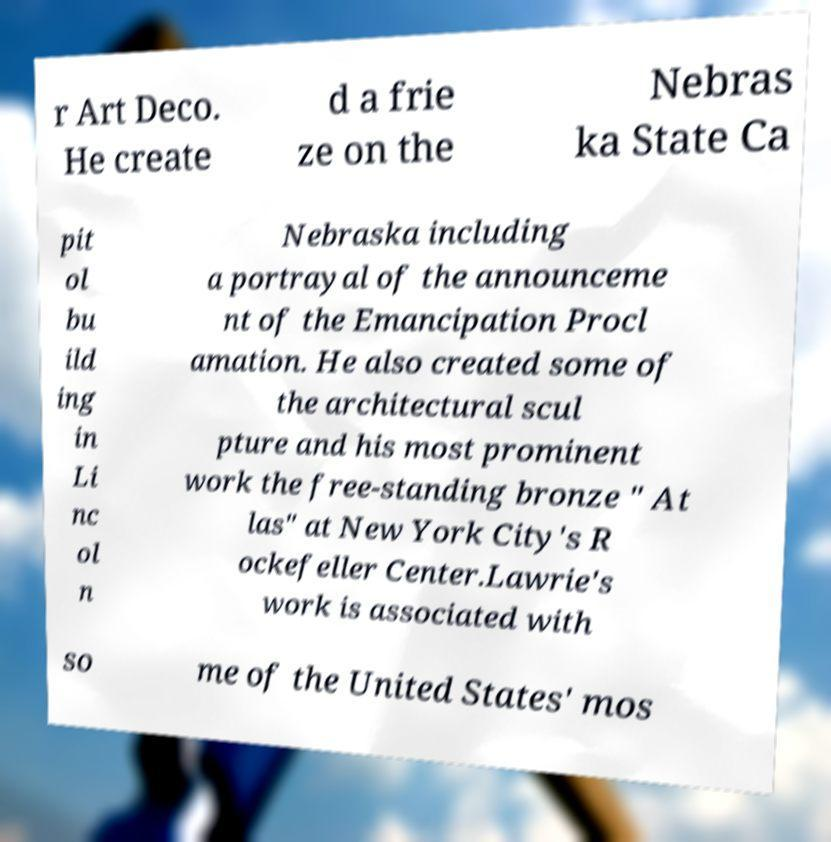Could you assist in decoding the text presented in this image and type it out clearly? r Art Deco. He create d a frie ze on the Nebras ka State Ca pit ol bu ild ing in Li nc ol n Nebraska including a portrayal of the announceme nt of the Emancipation Procl amation. He also created some of the architectural scul pture and his most prominent work the free-standing bronze " At las" at New York City's R ockefeller Center.Lawrie's work is associated with so me of the United States' mos 